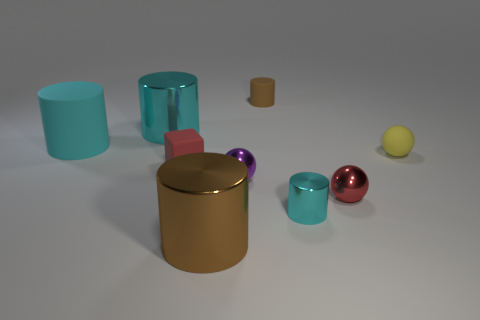Are there fewer cyan matte cylinders than large metal things?
Provide a succinct answer. Yes. There is a small yellow thing; are there any tiny red metallic things on the left side of it?
Offer a very short reply. Yes. What is the shape of the thing that is in front of the large cyan matte cylinder and left of the large brown object?
Your response must be concise. Cube. Is there another rubber thing of the same shape as the yellow matte object?
Make the answer very short. No. There is a red object that is right of the tiny purple thing; is it the same size as the brown object behind the small red sphere?
Your answer should be very brief. Yes. Are there more tiny brown cylinders than tiny yellow rubber blocks?
Keep it short and to the point. Yes. What number of brown cylinders have the same material as the small red cube?
Provide a short and direct response. 1. Is the shape of the tiny brown thing the same as the large brown shiny thing?
Provide a succinct answer. Yes. There is a matte object that is on the left side of the cyan cylinder that is behind the matte cylinder that is on the left side of the tiny red cube; what size is it?
Give a very brief answer. Large. Are there any tiny brown rubber cylinders that are behind the big brown cylinder in front of the small rubber cylinder?
Make the answer very short. Yes. 